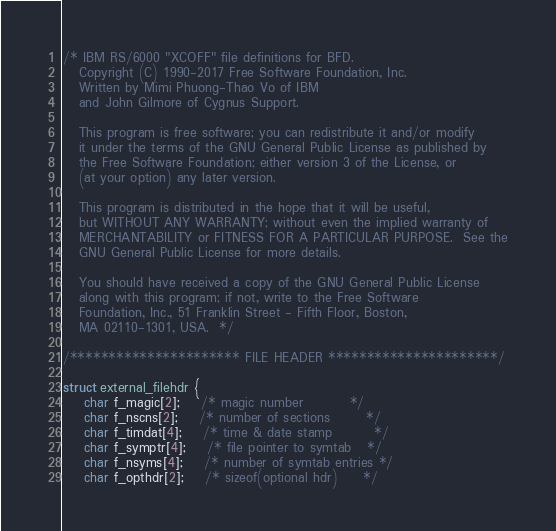<code> <loc_0><loc_0><loc_500><loc_500><_C_>/* IBM RS/6000 "XCOFF" file definitions for BFD.
   Copyright (C) 1990-2017 Free Software Foundation, Inc.
   Written by Mimi Phuong-Thao Vo of IBM
   and John Gilmore of Cygnus Support.

   This program is free software; you can redistribute it and/or modify
   it under the terms of the GNU General Public License as published by
   the Free Software Foundation; either version 3 of the License, or
   (at your option) any later version.

   This program is distributed in the hope that it will be useful,
   but WITHOUT ANY WARRANTY; without even the implied warranty of
   MERCHANTABILITY or FITNESS FOR A PARTICULAR PURPOSE.  See the
   GNU General Public License for more details.

   You should have received a copy of the GNU General Public License
   along with this program; if not, write to the Free Software
   Foundation, Inc., 51 Franklin Street - Fifth Floor, Boston,
   MA 02110-1301, USA.  */

/********************** FILE HEADER **********************/

struct external_filehdr {
	char f_magic[2];	/* magic number			*/
	char f_nscns[2];	/* number of sections		*/
	char f_timdat[4];	/* time & date stamp		*/
	char f_symptr[4];	/* file pointer to symtab	*/
	char f_nsyms[4];	/* number of symtab entries	*/
	char f_opthdr[2];	/* sizeof(optional hdr)		*/</code> 